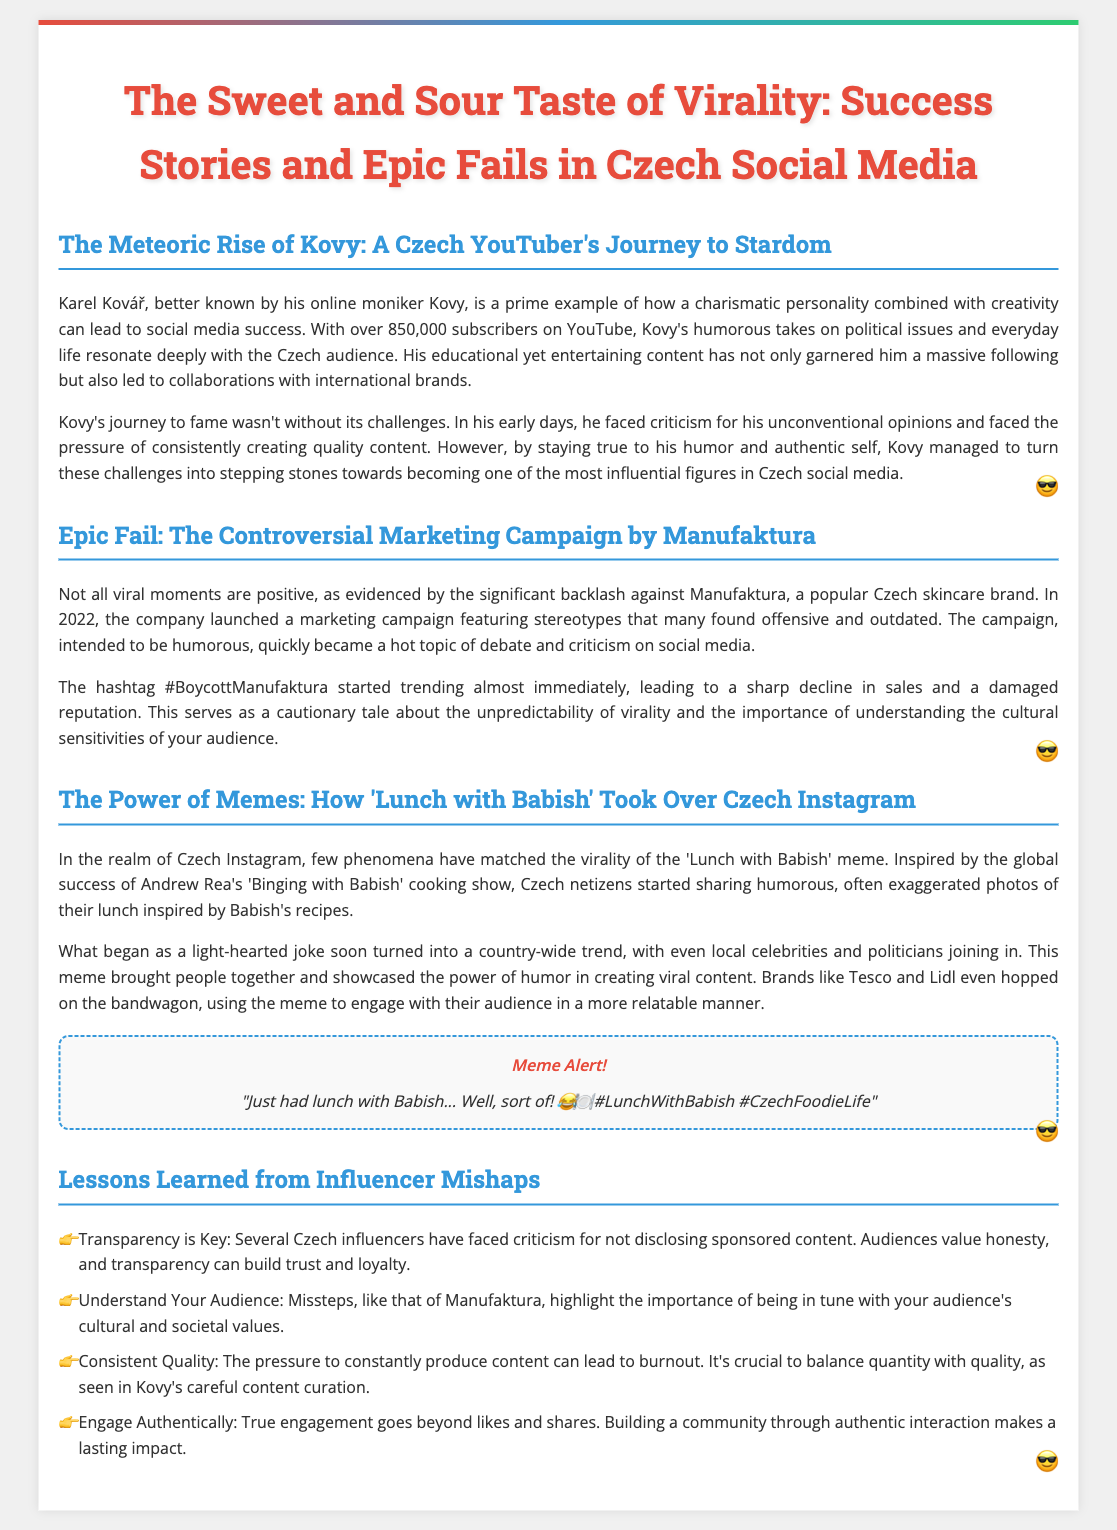What is Kovy's real name? Kovy's real name is Karel Kovář, as stated in the first section.
Answer: Karel Kovář How many YouTube subscribers does Kovy have? The document states that Kovy has over 850,000 subscribers on YouTube.
Answer: 850,000 What year did the Manufaktura campaign controversy occur? The document mentions that the Manufaktura campaign faced backlash in 2022.
Answer: 2022 What hashtag trended due to the Manufaktura campaign? The trending hashtag associated with the controversy was #BoycottManufaktura.
Answer: #BoycottManufaktura What inspired the 'Lunch with Babish' meme? The meme was inspired by Andrew Rea's cooking show 'Binging with Babish'.
Answer: 'Binging with Babish' What is one lesson learned from influencer mishaps? One lesson highlighted is that "Transparency is Key."
Answer: Transparency is Key How did the 'Lunch with Babish' meme impact brands? Brands like Tesco and Lidl used the meme to engage with their audience in a relatable manner.
Answer: Engaging with audience What is the main theme of the document? The document focuses on the successes and failures of social media virality in the Czech context.
Answer: Social media virality 